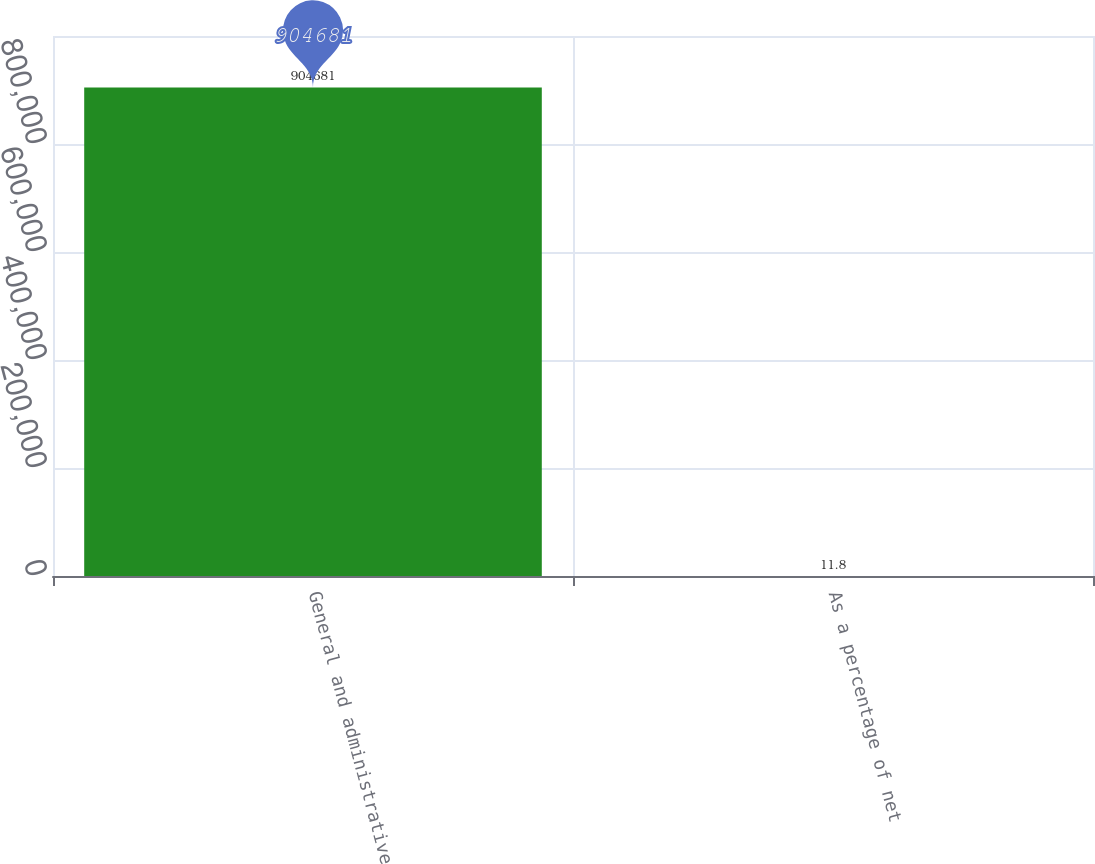Convert chart. <chart><loc_0><loc_0><loc_500><loc_500><bar_chart><fcel>General and administrative<fcel>As a percentage of net<nl><fcel>904681<fcel>11.8<nl></chart> 